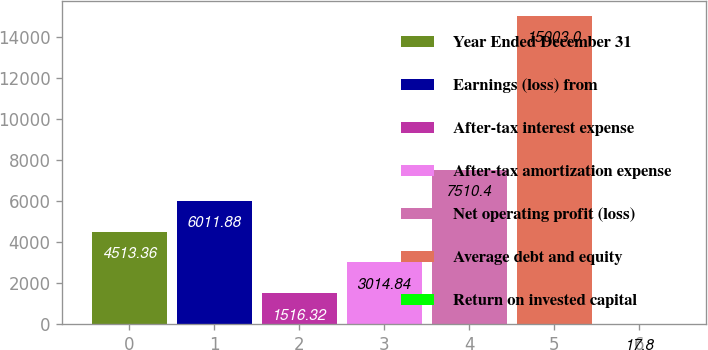Convert chart to OTSL. <chart><loc_0><loc_0><loc_500><loc_500><bar_chart><fcel>Year Ended December 31<fcel>Earnings (loss) from<fcel>After-tax interest expense<fcel>After-tax amortization expense<fcel>Net operating profit (loss)<fcel>Average debt and equity<fcel>Return on invested capital<nl><fcel>4513.36<fcel>6011.88<fcel>1516.32<fcel>3014.84<fcel>7510.4<fcel>15003<fcel>17.8<nl></chart> 